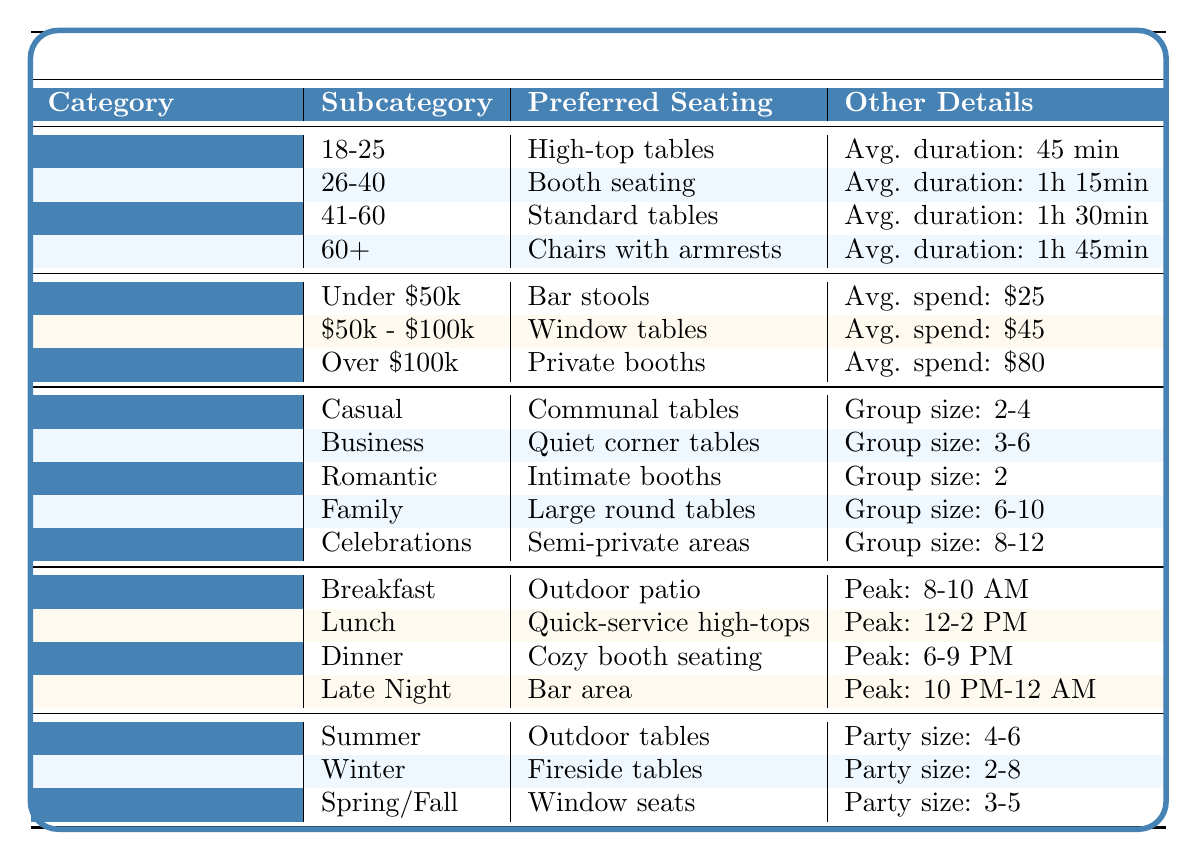What preferred seating do people aged 41-60 prefer? According to the table, people aged 41-60 prefer standard tables.
Answer: Standard tables What is the average dining duration for casual dining occasions? The table indicates that for casual dining, the average dining duration is 45 minutes (from the 18-25 age group as they frequent casual meetups).
Answer: 45 minutes Is booth seating preferred by the demographic with income levels between $50,000 - $100,000? Yes, the table indicates that this income group prefers window tables, so booth seating is not preferred by them.
Answer: No What is the preferred seating for family gatherings? The table specifies that family gatherings prefer large round tables for seating.
Answer: Large round tables In which season is outdoor seating most requested? The table states that outdoor tables are most requested during summer, as highlighted in the seasonality section.
Answer: Summer What is the average group size for romantic dining occasions? The table shows that for romantic dates, the average group size is 2 people.
Answer: 2 people Which age group has the longest average dining duration? Reviewing the table, it shows that the 60+ age group has an average dining duration of 1 hour 45 minutes, the longest among all age groups.
Answer: 60+ How much do customers earning over $100,000 spend on average per visit? According to the income levels section of the table, customers in this category spend an average of $80 per visit.
Answer: $80 Which seating preference corresponds to the busiest peak hour for lunch? The table states that during lunch, the preferred seating is quick-service high-tops, particularly during peak hours from 12:00 PM to 2:00 PM.
Answer: Quick-service high-tops From which demographics do most couples and families prefer seating during dinner? The table indicates that during dinner, cozy booth seating is preferred by couples and families, who are the most popular demographic during these hours.
Answer: Cozy booth seating In what situations do large round tables get used as preferred seating? The table indicates that large round tables are preferred during family gatherings, as they accommodate a larger group size of 6-10 people.
Answer: Family gatherings 